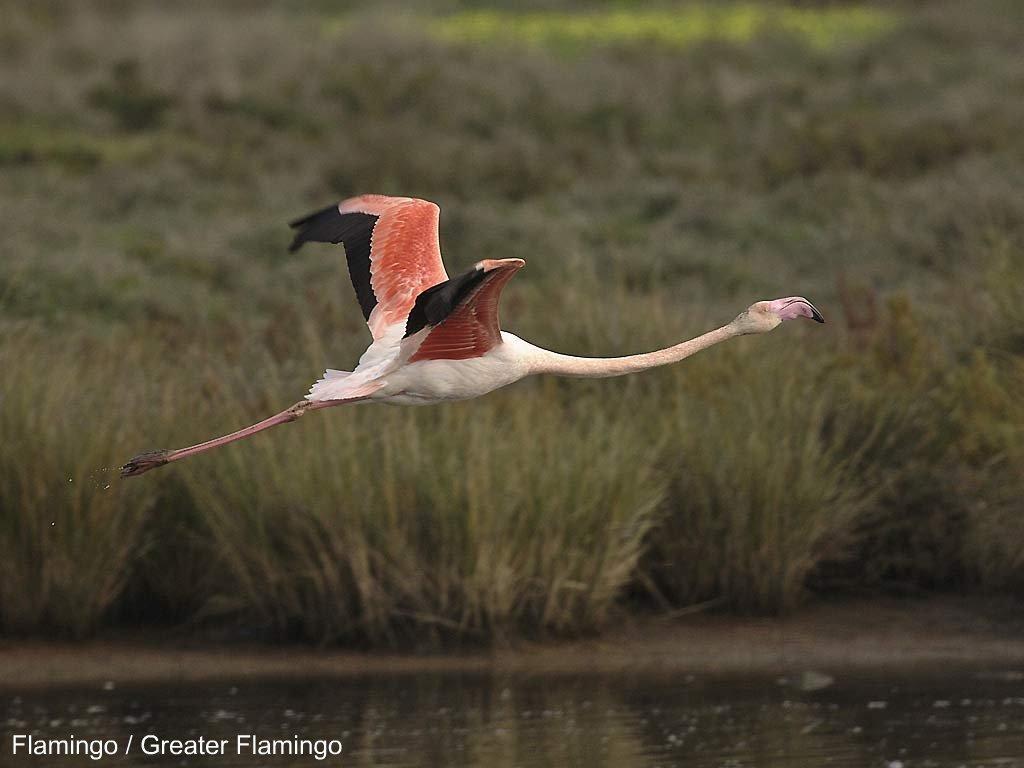How would you summarize this image in a sentence or two? In this image we can see a bird flying in the air, bushes and water. 